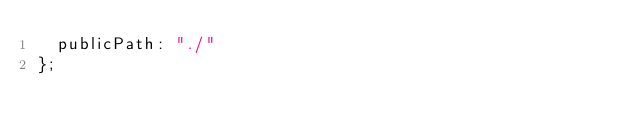<code> <loc_0><loc_0><loc_500><loc_500><_JavaScript_>  publicPath: "./" 
};</code> 